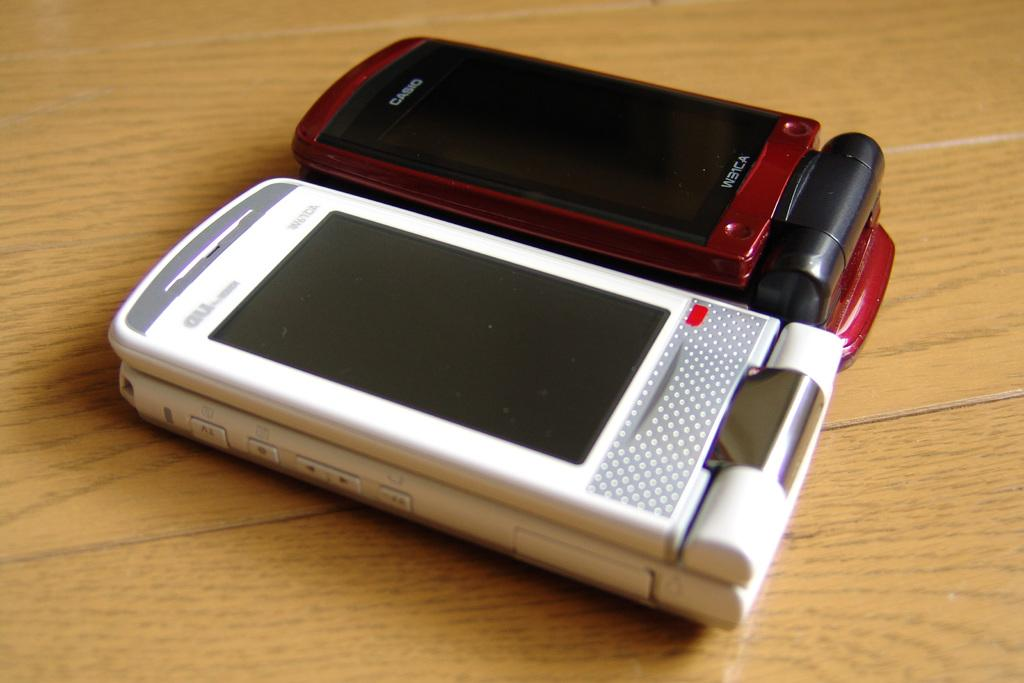<image>
Summarize the visual content of the image. A maroon Casio flip phone next to another white flip phone on a table 